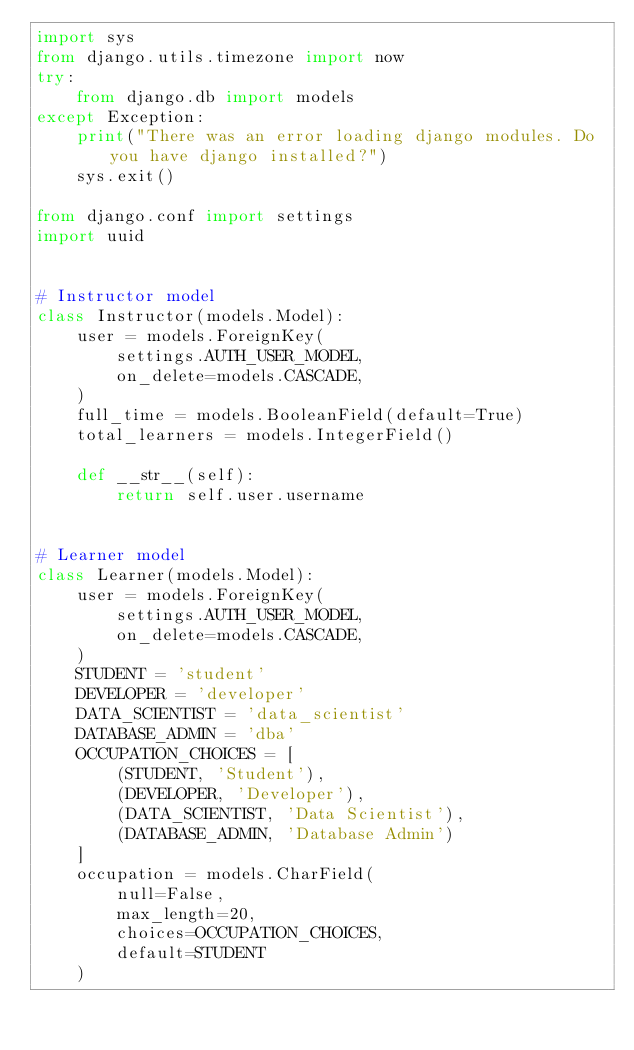<code> <loc_0><loc_0><loc_500><loc_500><_Python_>import sys
from django.utils.timezone import now
try:
    from django.db import models
except Exception:
    print("There was an error loading django modules. Do you have django installed?")
    sys.exit()

from django.conf import settings
import uuid


# Instructor model
class Instructor(models.Model):
    user = models.ForeignKey(
        settings.AUTH_USER_MODEL,
        on_delete=models.CASCADE,
    )
    full_time = models.BooleanField(default=True)
    total_learners = models.IntegerField()

    def __str__(self):
        return self.user.username


# Learner model
class Learner(models.Model):
    user = models.ForeignKey(
        settings.AUTH_USER_MODEL,
        on_delete=models.CASCADE,
    )
    STUDENT = 'student'
    DEVELOPER = 'developer'
    DATA_SCIENTIST = 'data_scientist'
    DATABASE_ADMIN = 'dba'
    OCCUPATION_CHOICES = [
        (STUDENT, 'Student'),
        (DEVELOPER, 'Developer'),
        (DATA_SCIENTIST, 'Data Scientist'),
        (DATABASE_ADMIN, 'Database Admin')
    ]
    occupation = models.CharField(
        null=False,
        max_length=20,
        choices=OCCUPATION_CHOICES,
        default=STUDENT
    )</code> 